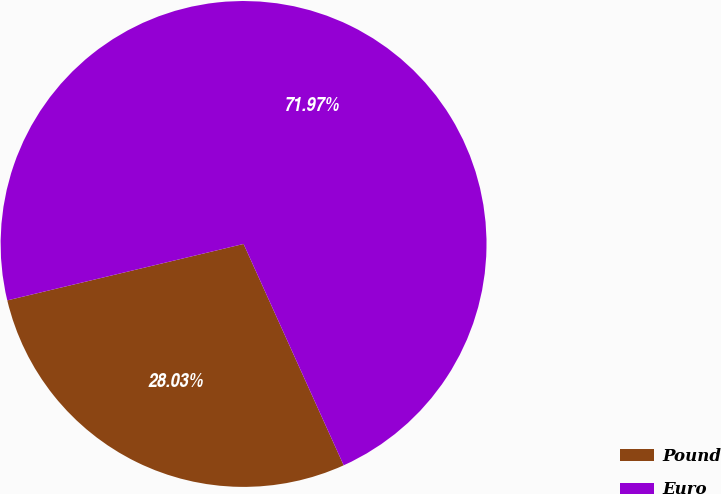<chart> <loc_0><loc_0><loc_500><loc_500><pie_chart><fcel>Pound<fcel>Euro<nl><fcel>28.03%<fcel>71.97%<nl></chart> 